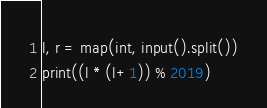Convert code to text. <code><loc_0><loc_0><loc_500><loc_500><_Python_>l, r = map(int, input().split())
print((l * (l+1)) % 2019)</code> 